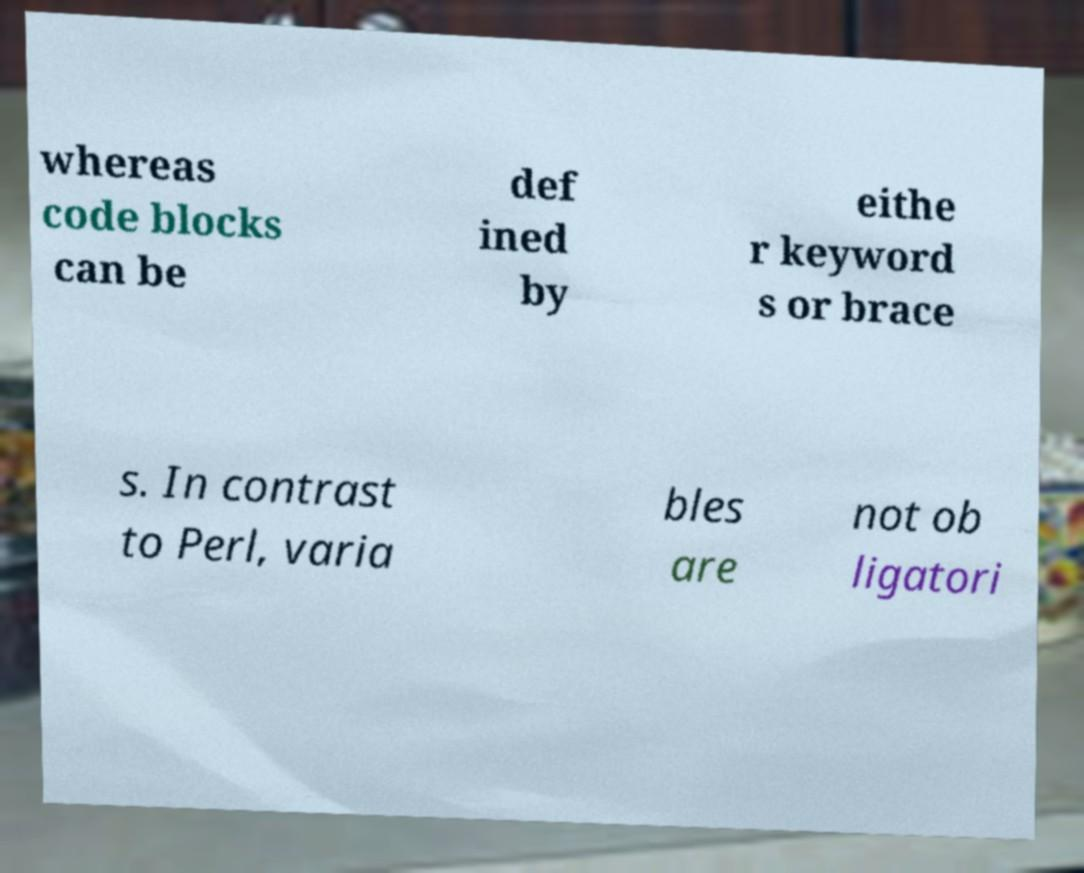Could you assist in decoding the text presented in this image and type it out clearly? whereas code blocks can be def ined by eithe r keyword s or brace s. In contrast to Perl, varia bles are not ob ligatori 